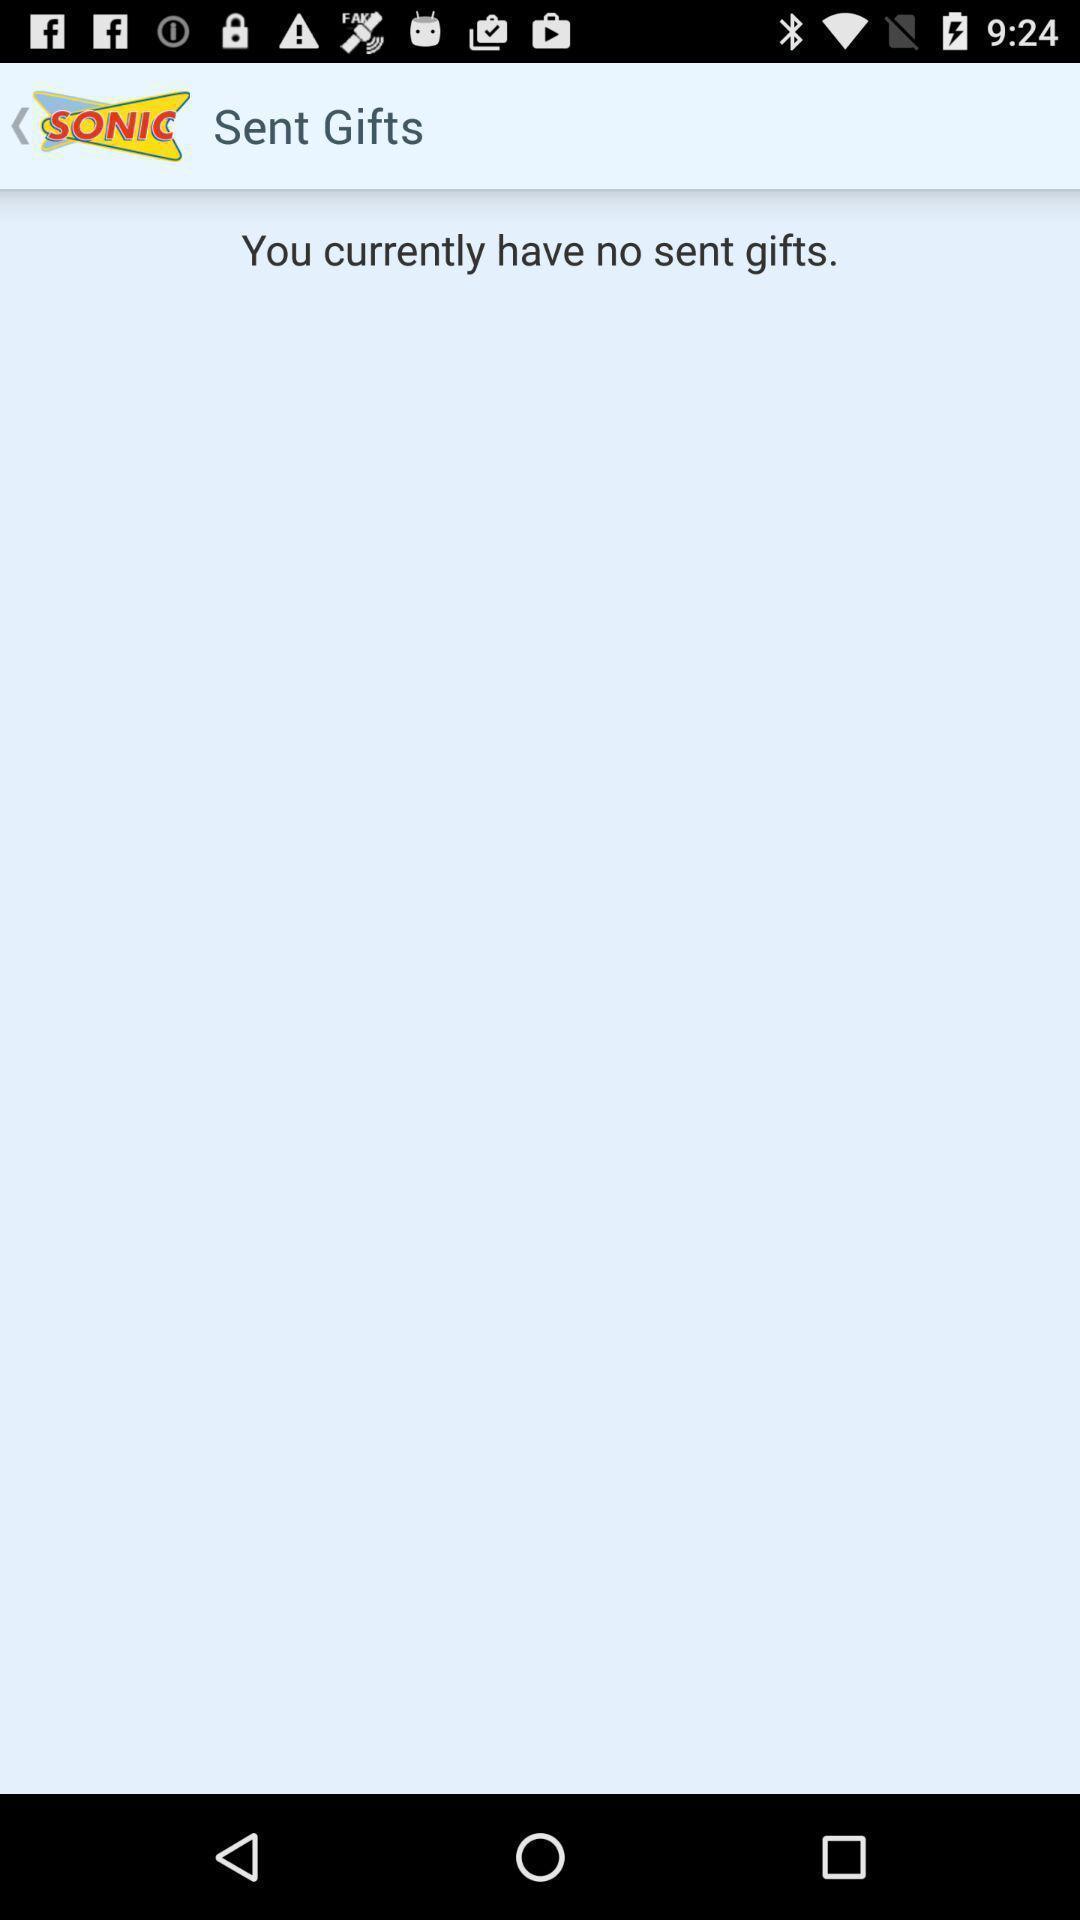Summarize the main components in this picture. Page displaying results for sent gifts. 